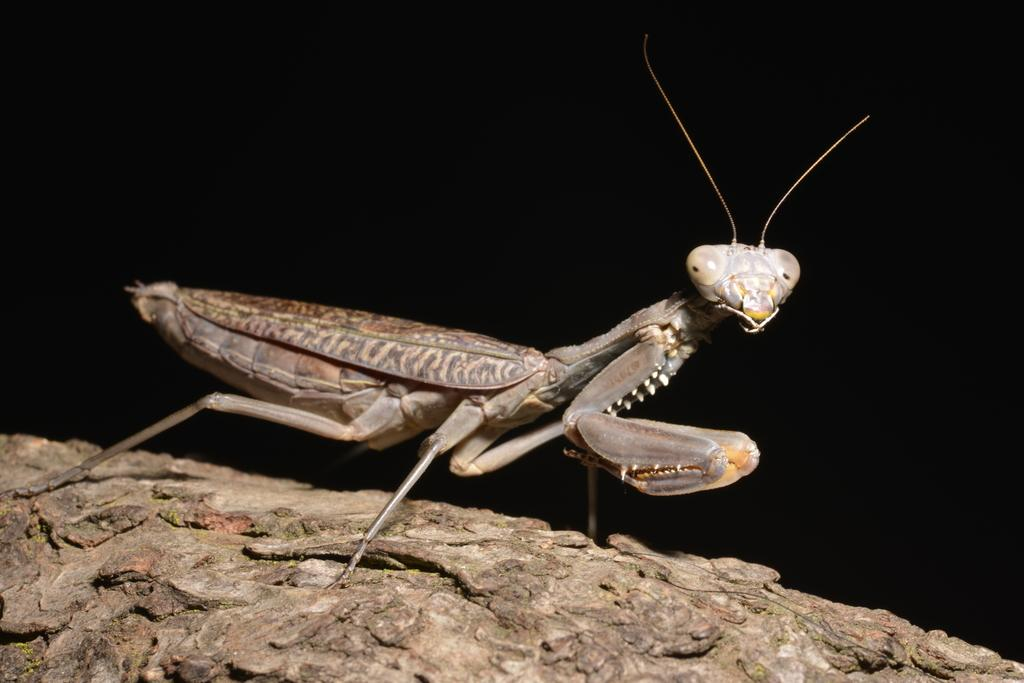What type of creature is present in the image? There is an insect in the image. What surface is the insect on? The insect is on a wooden surface. What can be observed about the background of the image? The background of the image is dark. What type of milk is the owl drinking in the image? There is no owl or milk present in the image; it features an insect on a wooden surface with a dark background. 